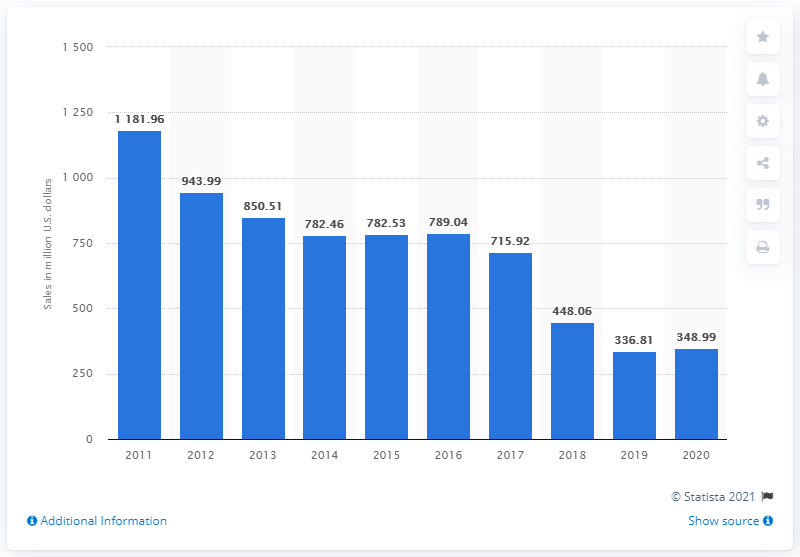Point out several critical features in this image. In 2020, the sales of Jack in the Box restaurants were 348.99. 